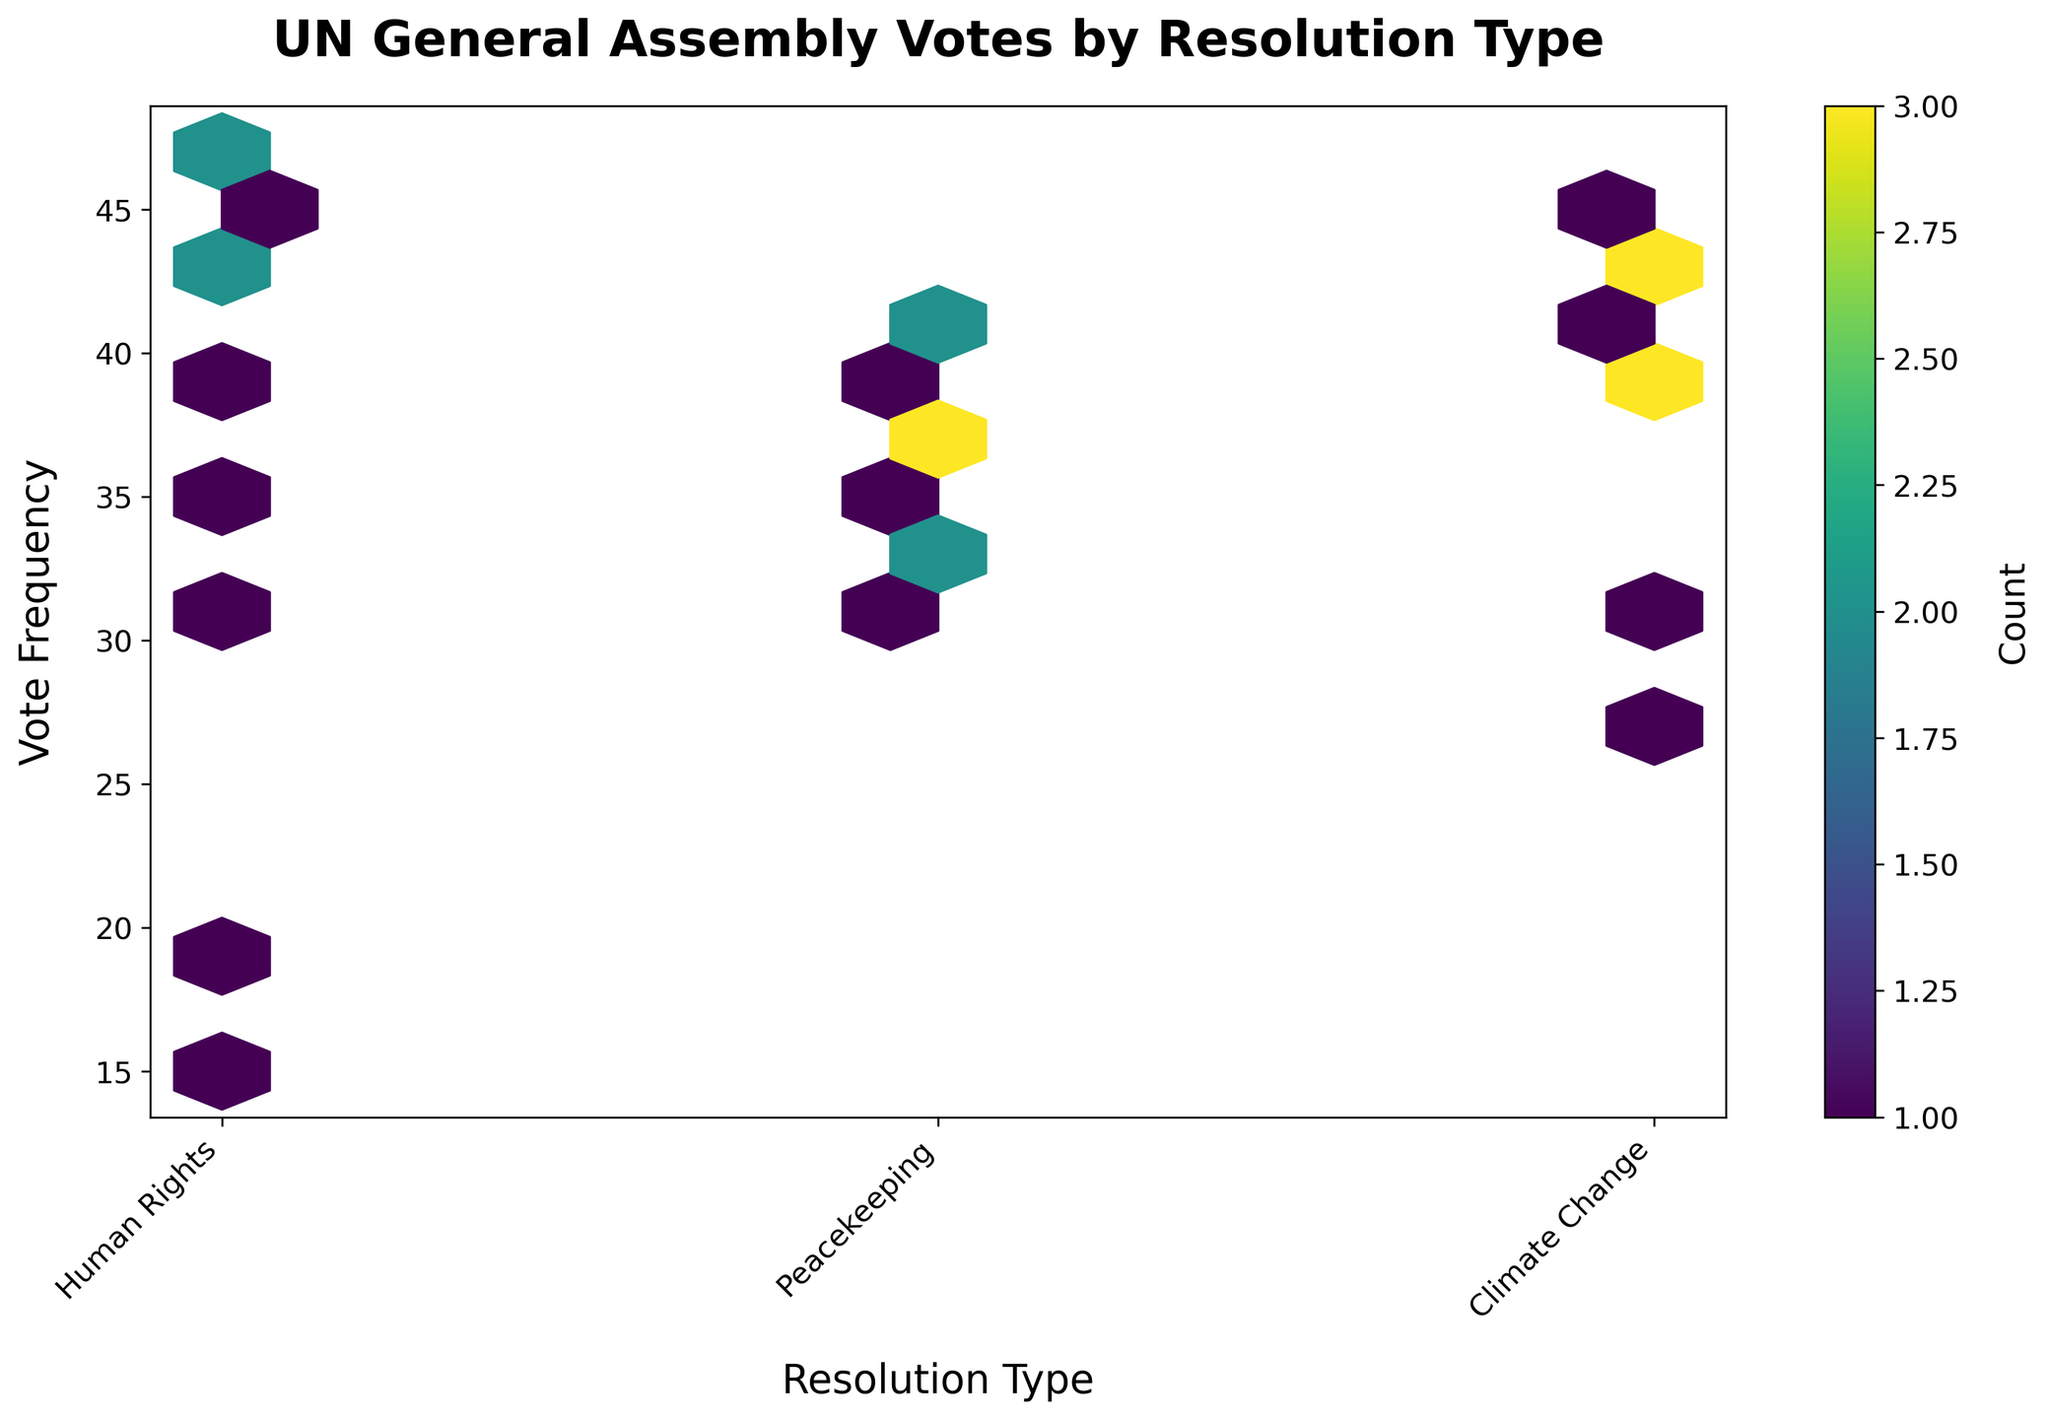What is the title of the plot? The title is shown at the top of the figure. The title is 'UN General Assembly Votes by Resolution Type'.
Answer: UN General Assembly Votes by Resolution Type What do the x-axis and y-axis represent in the plot? The x-axis represents the 'Resolution Type' while the y-axis represents the 'Vote Frequency'. These are typically labeled clearly on the axes.
Answer: x-axis: Resolution Type, y-axis: Vote Frequency How many resolution types are displayed on the x-axis? The x-axis has three tick labels corresponding to three resolution types: 'Human Rights', 'Peacekeeping', and 'Climate Change'.
Answer: 3 Which resolution type appears to have the highest vote frequency? By observing which hexagon has the highest y-coordinate for each x-tick, we can determine which resolution type has the highest vote frequency.
Answer: Climate Change In which range does the highest vote frequency fall for 'Human Rights' resolutions? By looking at the y-axis value of the highest hexagon for 'Human Rights', we can see that the highest vote frequency falls around 47.
Answer: Around 47 For which resolution type is the vote frequency distribution the most diverse? To find this, observe how spread out the hexagons are vertically for each resolution type. The more spread out, the more diverse the distribution.
Answer: Human Rights How many countries have a vote frequency of 40 for 'Peacekeeping'? To determine this, observe the number of hexagons at the x-tick for 'Peacekeeping' (1) that align with the y-value of 40.
Answer: 1 What is the average vote frequency for the 'Climate Change' resolution type? To compute this, sum all the vote frequencies for 'Climate Change' and divide by the number of data points (countries). Calculation: (28 + 38 + 30 + 44 + 43 + 39 + 41 + 42 + 45 + 40) / 10 = 39
Answer: 39 Which resolution type has the most clustered vote frequencies? By identifying which column on the hexbin plot has the densest clusters of hexagons, we see that 'Climate Change' has the densest clusters, indicating closely packed vote frequencies.
Answer: Climate Change 